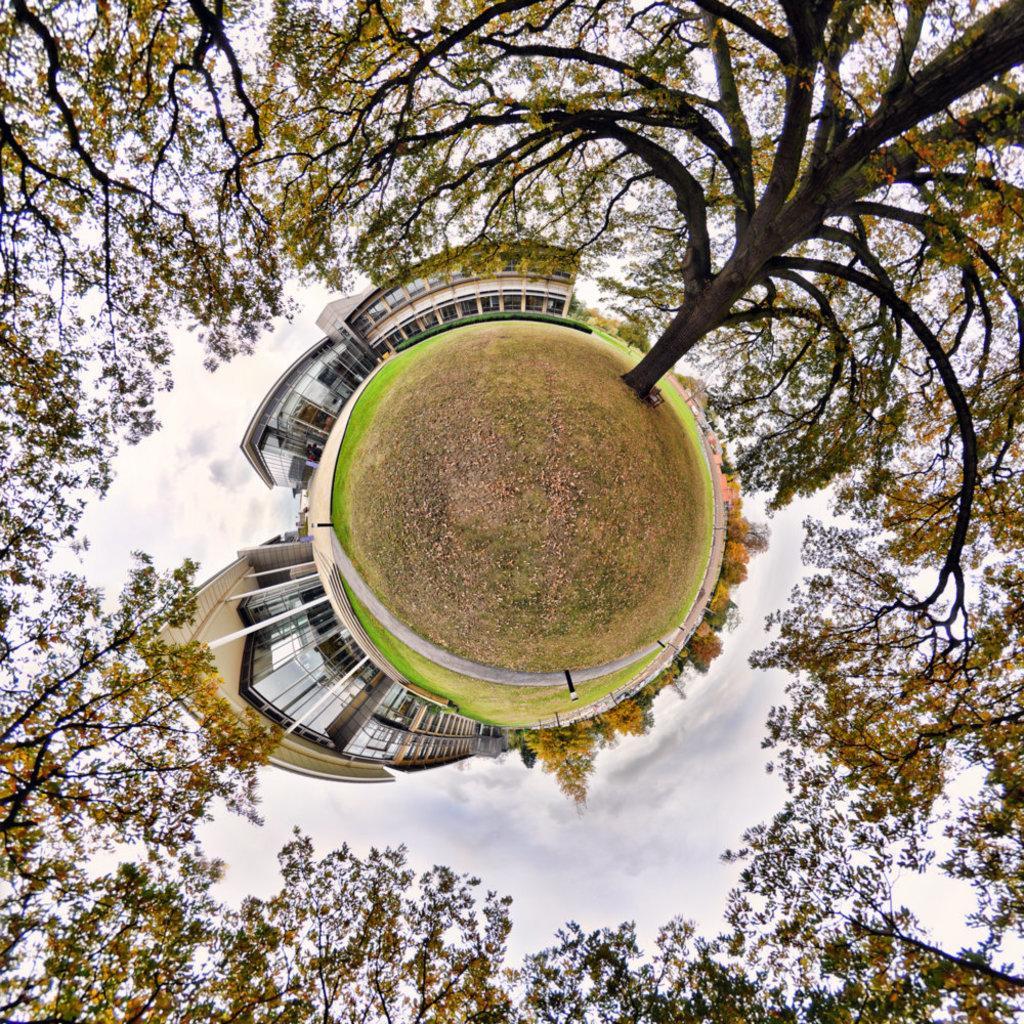How would you summarize this image in a sentence or two? These are the trees, in the middle it's a ground and there are buildings. 